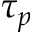<formula> <loc_0><loc_0><loc_500><loc_500>\tau _ { p }</formula> 